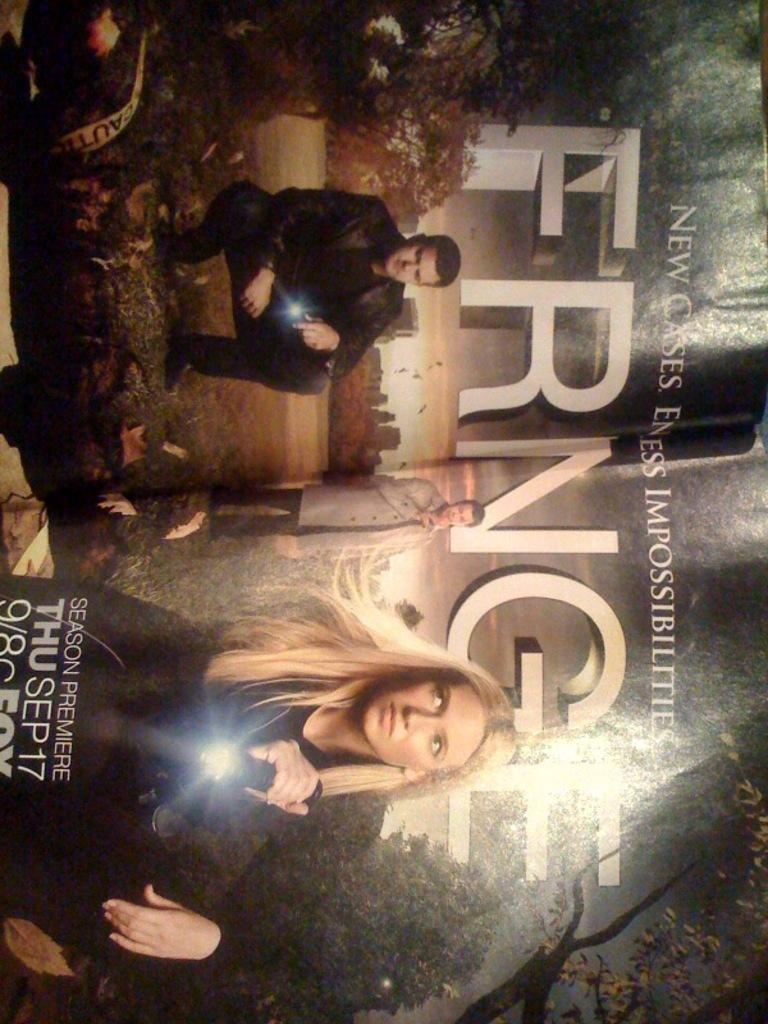What type of visual is the image? The image is a poster. Who or what is depicted in the image? There are people in the image. What type of natural environment is shown at the bottom of the image? There is grass at the bottom of the image. What other natural elements are present in the image? There are trees in the image. Is there any text on the image? Yes, there is text on the image. What is the price of the liquid being sold by the people in the image? There is no liquid or price mentioned in the image; it only shows people, grass, trees, and text. 